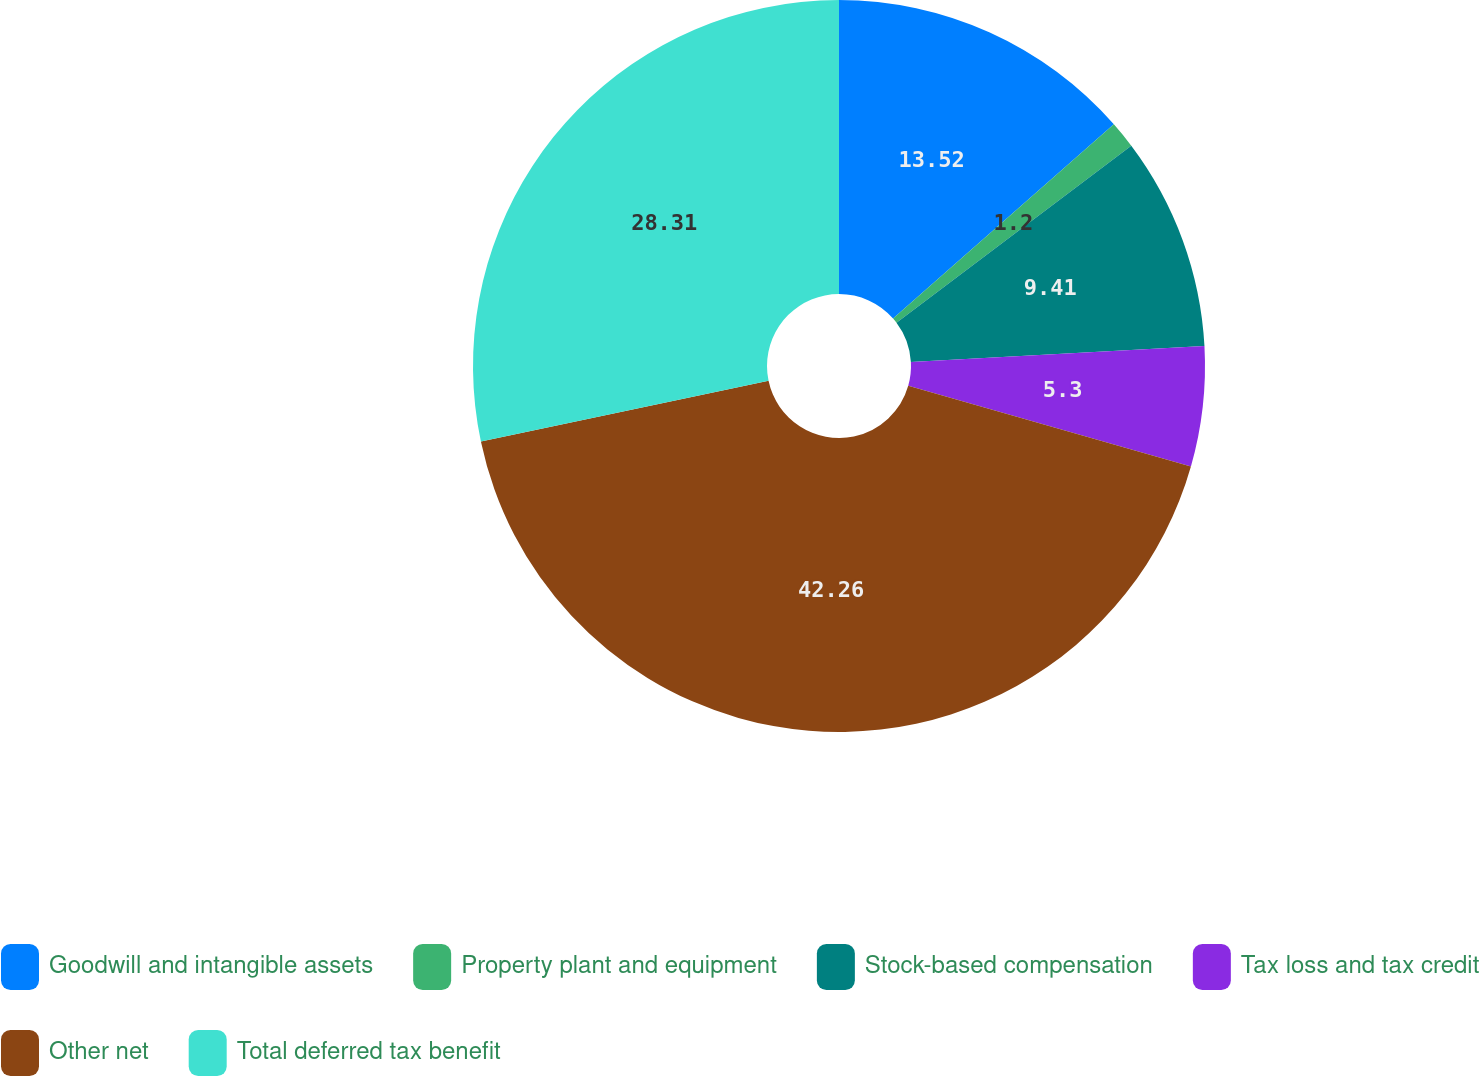<chart> <loc_0><loc_0><loc_500><loc_500><pie_chart><fcel>Goodwill and intangible assets<fcel>Property plant and equipment<fcel>Stock-based compensation<fcel>Tax loss and tax credit<fcel>Other net<fcel>Total deferred tax benefit<nl><fcel>13.52%<fcel>1.2%<fcel>9.41%<fcel>5.3%<fcel>42.26%<fcel>28.31%<nl></chart> 